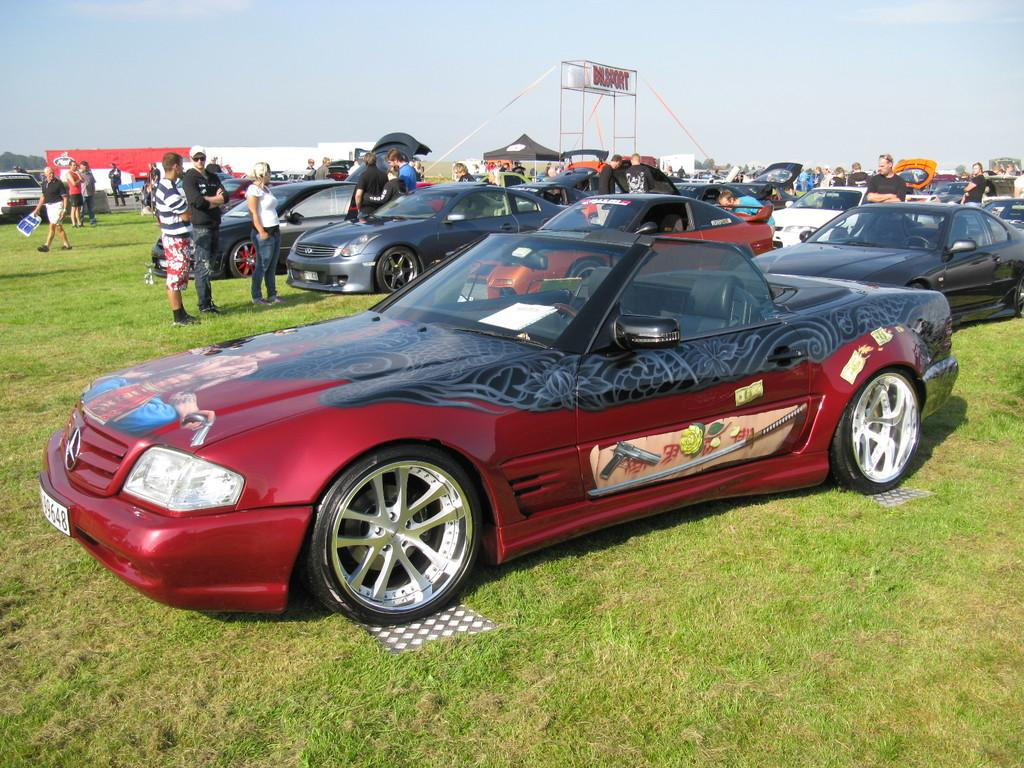What types of objects are on the ground in the image? There are vehicles on the ground in the image. What structures can be seen in the image? There are sheds in the image. What type of vegetation is present in the image? There are trees and grass in the image. Who or what is present in the image? There are people in the image. What architectural feature can be seen in the image? There is an arch in the image. What part of the natural environment is visible in the background of the image? The sky is visible in the background of the image. What day of the week is depicted in the image? The image does not depict a specific day of the week; it is a still image. What fact can be learned about the sister of the person taking the photo? There is no information about a sister or the person taking the photo in the image. 